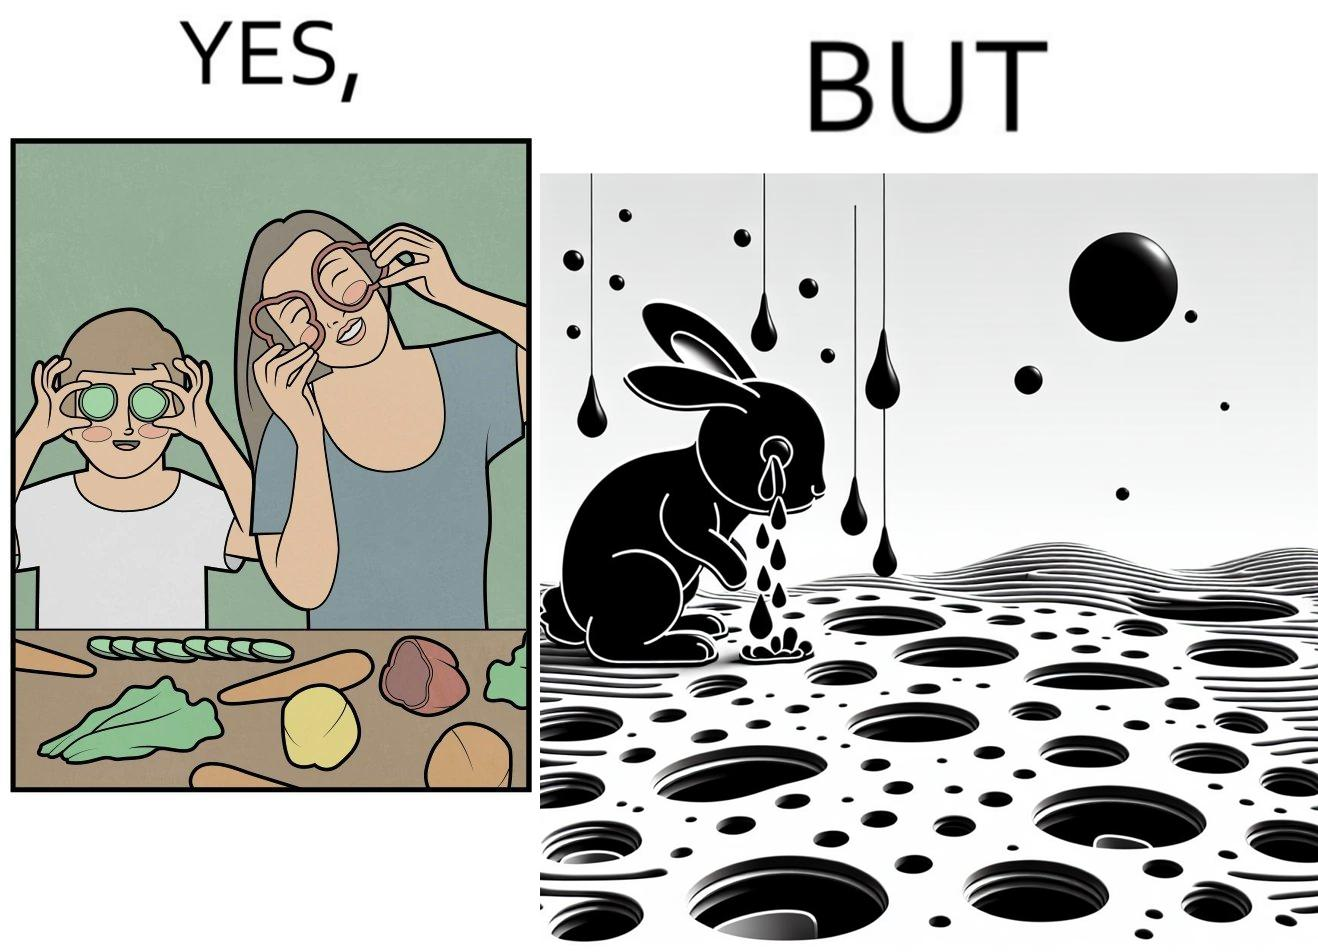Explain the humor or irony in this image. The images are ironic since they show how on one hand humans choose to play with and waste foods like vegetables while the animals are unable to eat enough food and end up starving due to lack of food 